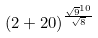Convert formula to latex. <formula><loc_0><loc_0><loc_500><loc_500>( 2 + 2 0 ) ^ { \frac { \sqrt { 9 } ^ { 1 0 } } { \sqrt { 8 } } }</formula> 